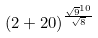Convert formula to latex. <formula><loc_0><loc_0><loc_500><loc_500>( 2 + 2 0 ) ^ { \frac { \sqrt { 9 } ^ { 1 0 } } { \sqrt { 8 } } }</formula> 